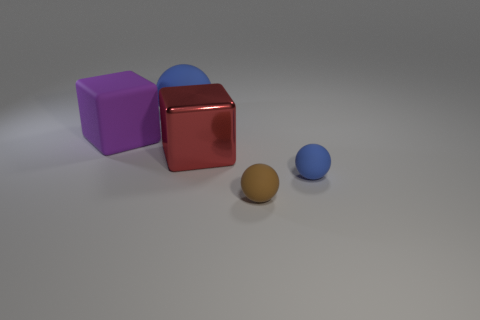How many small brown rubber things are in front of the large cube in front of the purple block?
Offer a terse response. 1. There is a tiny blue rubber object; are there any objects on the right side of it?
Ensure brevity in your answer.  No. There is a tiny object to the left of the small blue sphere; is its shape the same as the red object?
Give a very brief answer. No. There is a tiny sphere that is the same color as the large sphere; what is its material?
Offer a terse response. Rubber. How many other matte balls have the same color as the big ball?
Your response must be concise. 1. The thing that is left of the blue object that is on the left side of the red metallic object is what shape?
Offer a very short reply. Cube. Are there any other purple objects of the same shape as the large purple rubber object?
Your answer should be compact. No. There is a shiny cube; does it have the same color as the rubber block that is left of the large red metal cube?
Your answer should be very brief. No. What size is the other matte ball that is the same color as the large rubber sphere?
Your response must be concise. Small. Are there any gray matte objects that have the same size as the brown matte thing?
Offer a very short reply. No. 